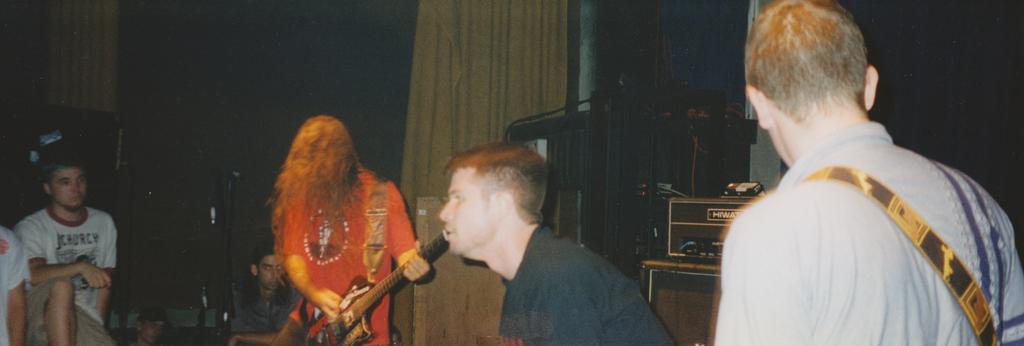Can you describe this image briefly? In the left, there are two persons. Out of which one person is sitting and one person is half visible. In the middle, there are two person. One is playing a guitar while standing and another is sitting. In the right, there is another person holding a guitar. In the background, curtain of yellow and dark in color is visible. In the bottom middle, a table is there on which a sound box is kept. This image is taken on the stage during night time. 